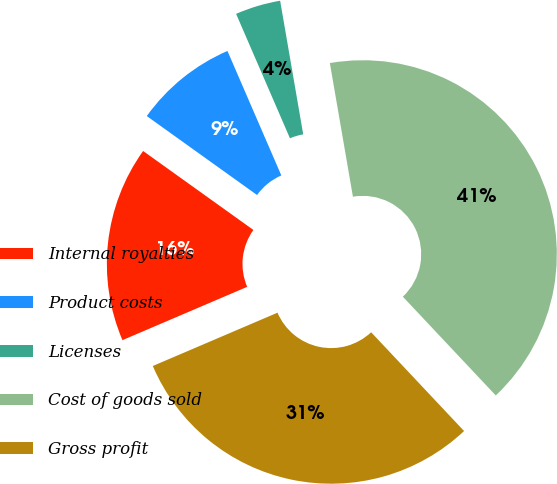Convert chart. <chart><loc_0><loc_0><loc_500><loc_500><pie_chart><fcel>Internal royalties<fcel>Product costs<fcel>Licenses<fcel>Cost of goods sold<fcel>Gross profit<nl><fcel>16.32%<fcel>8.61%<fcel>3.78%<fcel>40.71%<fcel>30.59%<nl></chart> 